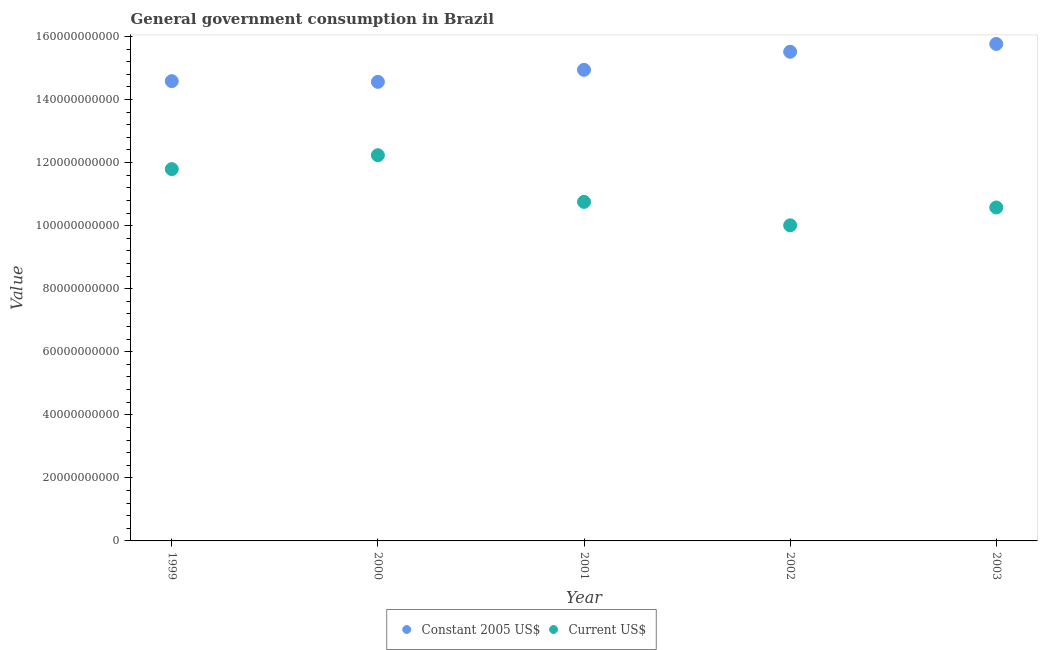How many different coloured dotlines are there?
Offer a terse response. 2. Is the number of dotlines equal to the number of legend labels?
Keep it short and to the point. Yes. What is the value consumed in current us$ in 2003?
Provide a succinct answer. 1.06e+11. Across all years, what is the maximum value consumed in current us$?
Your response must be concise. 1.22e+11. Across all years, what is the minimum value consumed in current us$?
Provide a succinct answer. 1.00e+11. What is the total value consumed in constant 2005 us$ in the graph?
Offer a terse response. 7.54e+11. What is the difference between the value consumed in current us$ in 2000 and that in 2003?
Your answer should be very brief. 1.66e+1. What is the difference between the value consumed in current us$ in 2001 and the value consumed in constant 2005 us$ in 2002?
Give a very brief answer. -4.76e+1. What is the average value consumed in constant 2005 us$ per year?
Give a very brief answer. 1.51e+11. In the year 2001, what is the difference between the value consumed in current us$ and value consumed in constant 2005 us$?
Offer a terse response. -4.19e+1. In how many years, is the value consumed in current us$ greater than 148000000000?
Your answer should be very brief. 0. What is the ratio of the value consumed in current us$ in 1999 to that in 2002?
Make the answer very short. 1.18. Is the difference between the value consumed in constant 2005 us$ in 1999 and 2001 greater than the difference between the value consumed in current us$ in 1999 and 2001?
Make the answer very short. No. What is the difference between the highest and the second highest value consumed in constant 2005 us$?
Provide a succinct answer. 2.48e+09. What is the difference between the highest and the lowest value consumed in constant 2005 us$?
Make the answer very short. 1.20e+1. In how many years, is the value consumed in constant 2005 us$ greater than the average value consumed in constant 2005 us$ taken over all years?
Give a very brief answer. 2. Does the value consumed in constant 2005 us$ monotonically increase over the years?
Provide a short and direct response. No. Is the value consumed in current us$ strictly greater than the value consumed in constant 2005 us$ over the years?
Provide a succinct answer. No. What is the difference between two consecutive major ticks on the Y-axis?
Provide a short and direct response. 2.00e+1. Does the graph contain any zero values?
Your answer should be very brief. No. Does the graph contain grids?
Your response must be concise. No. How are the legend labels stacked?
Provide a succinct answer. Horizontal. What is the title of the graph?
Ensure brevity in your answer.  General government consumption in Brazil. What is the label or title of the Y-axis?
Your answer should be compact. Value. What is the Value of Constant 2005 US$ in 1999?
Make the answer very short. 1.46e+11. What is the Value of Current US$ in 1999?
Offer a very short reply. 1.18e+11. What is the Value of Constant 2005 US$ in 2000?
Ensure brevity in your answer.  1.46e+11. What is the Value in Current US$ in 2000?
Offer a terse response. 1.22e+11. What is the Value of Constant 2005 US$ in 2001?
Your answer should be compact. 1.49e+11. What is the Value of Current US$ in 2001?
Your answer should be very brief. 1.08e+11. What is the Value of Constant 2005 US$ in 2002?
Your answer should be very brief. 1.55e+11. What is the Value in Current US$ in 2002?
Ensure brevity in your answer.  1.00e+11. What is the Value in Constant 2005 US$ in 2003?
Provide a succinct answer. 1.58e+11. What is the Value of Current US$ in 2003?
Offer a terse response. 1.06e+11. Across all years, what is the maximum Value of Constant 2005 US$?
Your response must be concise. 1.58e+11. Across all years, what is the maximum Value in Current US$?
Offer a terse response. 1.22e+11. Across all years, what is the minimum Value in Constant 2005 US$?
Keep it short and to the point. 1.46e+11. Across all years, what is the minimum Value of Current US$?
Keep it short and to the point. 1.00e+11. What is the total Value in Constant 2005 US$ in the graph?
Offer a very short reply. 7.54e+11. What is the total Value in Current US$ in the graph?
Your answer should be compact. 5.54e+11. What is the difference between the Value of Constant 2005 US$ in 1999 and that in 2000?
Provide a short and direct response. 2.20e+08. What is the difference between the Value of Current US$ in 1999 and that in 2000?
Your answer should be compact. -4.41e+09. What is the difference between the Value of Constant 2005 US$ in 1999 and that in 2001?
Give a very brief answer. -3.59e+09. What is the difference between the Value of Current US$ in 1999 and that in 2001?
Make the answer very short. 1.04e+1. What is the difference between the Value in Constant 2005 US$ in 1999 and that in 2002?
Provide a short and direct response. -9.33e+09. What is the difference between the Value of Current US$ in 1999 and that in 2002?
Offer a very short reply. 1.78e+1. What is the difference between the Value of Constant 2005 US$ in 1999 and that in 2003?
Keep it short and to the point. -1.18e+1. What is the difference between the Value of Current US$ in 1999 and that in 2003?
Ensure brevity in your answer.  1.22e+1. What is the difference between the Value of Constant 2005 US$ in 2000 and that in 2001?
Make the answer very short. -3.81e+09. What is the difference between the Value in Current US$ in 2000 and that in 2001?
Provide a succinct answer. 1.48e+1. What is the difference between the Value of Constant 2005 US$ in 2000 and that in 2002?
Give a very brief answer. -9.55e+09. What is the difference between the Value in Current US$ in 2000 and that in 2002?
Your answer should be very brief. 2.22e+1. What is the difference between the Value of Constant 2005 US$ in 2000 and that in 2003?
Give a very brief answer. -1.20e+1. What is the difference between the Value of Current US$ in 2000 and that in 2003?
Keep it short and to the point. 1.66e+1. What is the difference between the Value in Constant 2005 US$ in 2001 and that in 2002?
Ensure brevity in your answer.  -5.73e+09. What is the difference between the Value in Current US$ in 2001 and that in 2002?
Ensure brevity in your answer.  7.43e+09. What is the difference between the Value of Constant 2005 US$ in 2001 and that in 2003?
Offer a terse response. -8.21e+09. What is the difference between the Value in Current US$ in 2001 and that in 2003?
Your answer should be very brief. 1.77e+09. What is the difference between the Value in Constant 2005 US$ in 2002 and that in 2003?
Offer a terse response. -2.48e+09. What is the difference between the Value of Current US$ in 2002 and that in 2003?
Offer a terse response. -5.66e+09. What is the difference between the Value of Constant 2005 US$ in 1999 and the Value of Current US$ in 2000?
Your answer should be very brief. 2.35e+1. What is the difference between the Value in Constant 2005 US$ in 1999 and the Value in Current US$ in 2001?
Provide a succinct answer. 3.83e+1. What is the difference between the Value of Constant 2005 US$ in 1999 and the Value of Current US$ in 2002?
Ensure brevity in your answer.  4.57e+1. What is the difference between the Value in Constant 2005 US$ in 1999 and the Value in Current US$ in 2003?
Make the answer very short. 4.01e+1. What is the difference between the Value of Constant 2005 US$ in 2000 and the Value of Current US$ in 2001?
Make the answer very short. 3.81e+1. What is the difference between the Value of Constant 2005 US$ in 2000 and the Value of Current US$ in 2002?
Give a very brief answer. 4.55e+1. What is the difference between the Value of Constant 2005 US$ in 2000 and the Value of Current US$ in 2003?
Give a very brief answer. 3.98e+1. What is the difference between the Value of Constant 2005 US$ in 2001 and the Value of Current US$ in 2002?
Make the answer very short. 4.93e+1. What is the difference between the Value of Constant 2005 US$ in 2001 and the Value of Current US$ in 2003?
Give a very brief answer. 4.36e+1. What is the difference between the Value of Constant 2005 US$ in 2002 and the Value of Current US$ in 2003?
Your answer should be very brief. 4.94e+1. What is the average Value of Constant 2005 US$ per year?
Make the answer very short. 1.51e+11. What is the average Value in Current US$ per year?
Provide a succinct answer. 1.11e+11. In the year 1999, what is the difference between the Value in Constant 2005 US$ and Value in Current US$?
Ensure brevity in your answer.  2.79e+1. In the year 2000, what is the difference between the Value of Constant 2005 US$ and Value of Current US$?
Provide a succinct answer. 2.33e+1. In the year 2001, what is the difference between the Value in Constant 2005 US$ and Value in Current US$?
Your answer should be compact. 4.19e+1. In the year 2002, what is the difference between the Value of Constant 2005 US$ and Value of Current US$?
Offer a terse response. 5.50e+1. In the year 2003, what is the difference between the Value in Constant 2005 US$ and Value in Current US$?
Give a very brief answer. 5.19e+1. What is the ratio of the Value of Constant 2005 US$ in 1999 to that in 2000?
Make the answer very short. 1. What is the ratio of the Value of Constant 2005 US$ in 1999 to that in 2001?
Provide a short and direct response. 0.98. What is the ratio of the Value of Current US$ in 1999 to that in 2001?
Your answer should be compact. 1.1. What is the ratio of the Value in Constant 2005 US$ in 1999 to that in 2002?
Provide a succinct answer. 0.94. What is the ratio of the Value in Current US$ in 1999 to that in 2002?
Make the answer very short. 1.18. What is the ratio of the Value of Constant 2005 US$ in 1999 to that in 2003?
Provide a short and direct response. 0.93. What is the ratio of the Value in Current US$ in 1999 to that in 2003?
Keep it short and to the point. 1.11. What is the ratio of the Value of Constant 2005 US$ in 2000 to that in 2001?
Your response must be concise. 0.97. What is the ratio of the Value in Current US$ in 2000 to that in 2001?
Provide a short and direct response. 1.14. What is the ratio of the Value of Constant 2005 US$ in 2000 to that in 2002?
Your response must be concise. 0.94. What is the ratio of the Value in Current US$ in 2000 to that in 2002?
Offer a very short reply. 1.22. What is the ratio of the Value of Constant 2005 US$ in 2000 to that in 2003?
Your response must be concise. 0.92. What is the ratio of the Value of Current US$ in 2000 to that in 2003?
Make the answer very short. 1.16. What is the ratio of the Value of Constant 2005 US$ in 2001 to that in 2002?
Offer a very short reply. 0.96. What is the ratio of the Value in Current US$ in 2001 to that in 2002?
Make the answer very short. 1.07. What is the ratio of the Value in Constant 2005 US$ in 2001 to that in 2003?
Your answer should be very brief. 0.95. What is the ratio of the Value in Current US$ in 2001 to that in 2003?
Give a very brief answer. 1.02. What is the ratio of the Value in Constant 2005 US$ in 2002 to that in 2003?
Keep it short and to the point. 0.98. What is the ratio of the Value of Current US$ in 2002 to that in 2003?
Your answer should be compact. 0.95. What is the difference between the highest and the second highest Value in Constant 2005 US$?
Ensure brevity in your answer.  2.48e+09. What is the difference between the highest and the second highest Value in Current US$?
Offer a very short reply. 4.41e+09. What is the difference between the highest and the lowest Value in Constant 2005 US$?
Your answer should be compact. 1.20e+1. What is the difference between the highest and the lowest Value in Current US$?
Offer a terse response. 2.22e+1. 